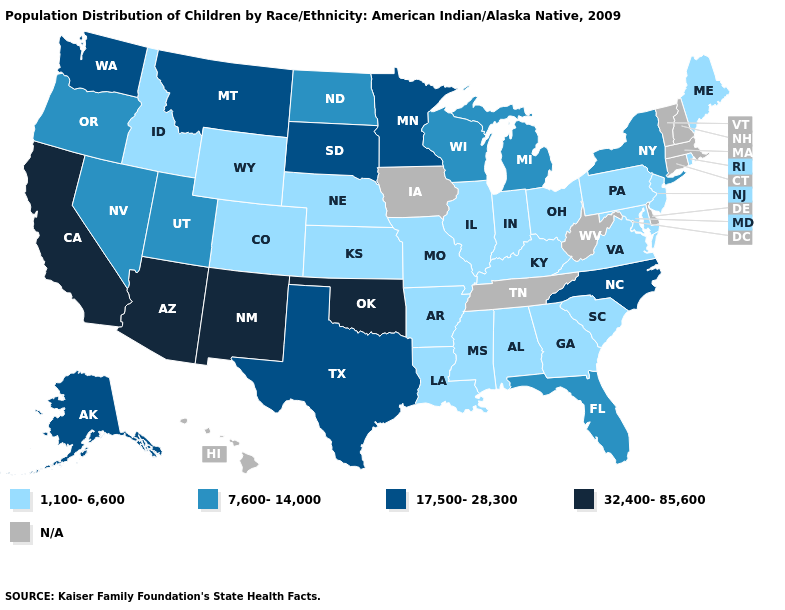What is the value of Vermont?
Answer briefly. N/A. Does the map have missing data?
Keep it brief. Yes. What is the highest value in states that border Michigan?
Write a very short answer. 7,600-14,000. What is the value of Florida?
Keep it brief. 7,600-14,000. Does the first symbol in the legend represent the smallest category?
Short answer required. Yes. Is the legend a continuous bar?
Answer briefly. No. What is the value of Ohio?
Quick response, please. 1,100-6,600. Name the states that have a value in the range 17,500-28,300?
Short answer required. Alaska, Minnesota, Montana, North Carolina, South Dakota, Texas, Washington. What is the value of Georgia?
Be succinct. 1,100-6,600. Name the states that have a value in the range N/A?
Short answer required. Connecticut, Delaware, Hawaii, Iowa, Massachusetts, New Hampshire, Tennessee, Vermont, West Virginia. What is the value of Washington?
Write a very short answer. 17,500-28,300. How many symbols are there in the legend?
Be succinct. 5. Name the states that have a value in the range 1,100-6,600?
Be succinct. Alabama, Arkansas, Colorado, Georgia, Idaho, Illinois, Indiana, Kansas, Kentucky, Louisiana, Maine, Maryland, Mississippi, Missouri, Nebraska, New Jersey, Ohio, Pennsylvania, Rhode Island, South Carolina, Virginia, Wyoming. Does the first symbol in the legend represent the smallest category?
Short answer required. Yes. 